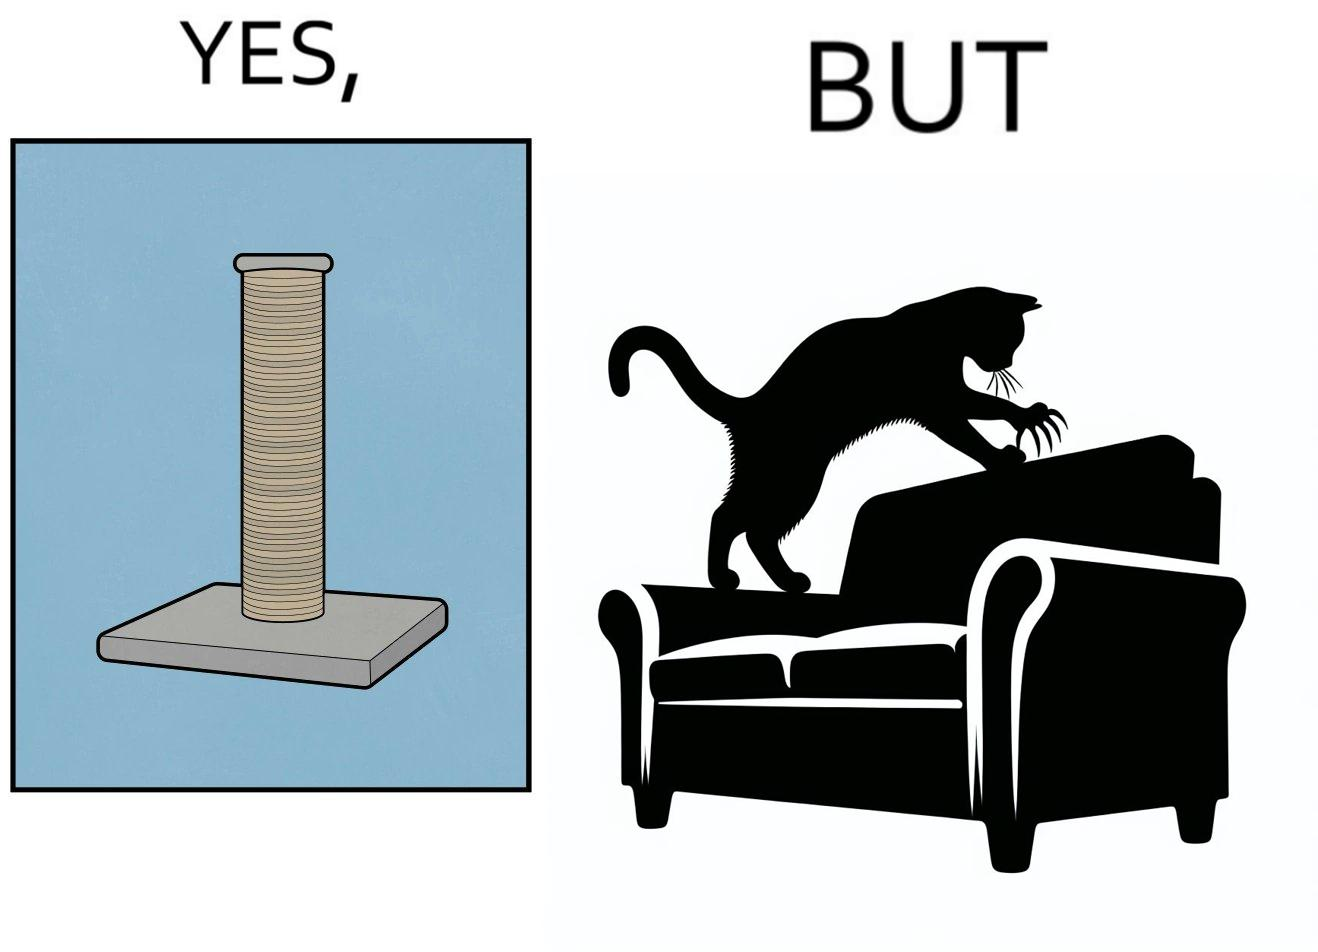Is this image satirical or non-satirical? Yes, this image is satirical. 